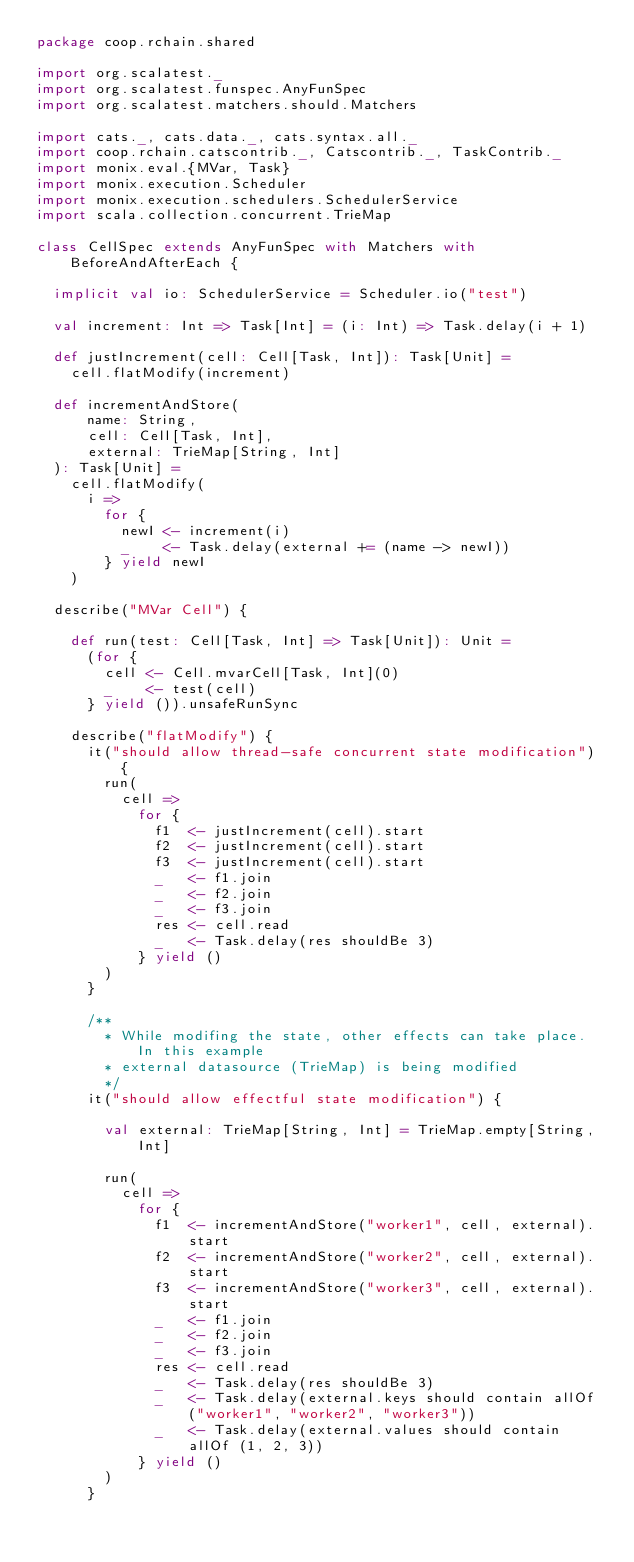Convert code to text. <code><loc_0><loc_0><loc_500><loc_500><_Scala_>package coop.rchain.shared

import org.scalatest._
import org.scalatest.funspec.AnyFunSpec
import org.scalatest.matchers.should.Matchers

import cats._, cats.data._, cats.syntax.all._
import coop.rchain.catscontrib._, Catscontrib._, TaskContrib._
import monix.eval.{MVar, Task}
import monix.execution.Scheduler
import monix.execution.schedulers.SchedulerService
import scala.collection.concurrent.TrieMap

class CellSpec extends AnyFunSpec with Matchers with BeforeAndAfterEach {

  implicit val io: SchedulerService = Scheduler.io("test")

  val increment: Int => Task[Int] = (i: Int) => Task.delay(i + 1)

  def justIncrement(cell: Cell[Task, Int]): Task[Unit] =
    cell.flatModify(increment)

  def incrementAndStore(
      name: String,
      cell: Cell[Task, Int],
      external: TrieMap[String, Int]
  ): Task[Unit] =
    cell.flatModify(
      i =>
        for {
          newI <- increment(i)
          _    <- Task.delay(external += (name -> newI))
        } yield newI
    )

  describe("MVar Cell") {

    def run(test: Cell[Task, Int] => Task[Unit]): Unit =
      (for {
        cell <- Cell.mvarCell[Task, Int](0)
        _    <- test(cell)
      } yield ()).unsafeRunSync

    describe("flatModify") {
      it("should allow thread-safe concurrent state modification") {
        run(
          cell =>
            for {
              f1  <- justIncrement(cell).start
              f2  <- justIncrement(cell).start
              f3  <- justIncrement(cell).start
              _   <- f1.join
              _   <- f2.join
              _   <- f3.join
              res <- cell.read
              _   <- Task.delay(res shouldBe 3)
            } yield ()
        )
      }

      /**
        * While modifing the state, other effects can take place. In this example
        * external datasource (TrieMap) is being modified
        */
      it("should allow effectful state modification") {

        val external: TrieMap[String, Int] = TrieMap.empty[String, Int]

        run(
          cell =>
            for {
              f1  <- incrementAndStore("worker1", cell, external).start
              f2  <- incrementAndStore("worker2", cell, external).start
              f3  <- incrementAndStore("worker3", cell, external).start
              _   <- f1.join
              _   <- f2.join
              _   <- f3.join
              res <- cell.read
              _   <- Task.delay(res shouldBe 3)
              _   <- Task.delay(external.keys should contain allOf ("worker1", "worker2", "worker3"))
              _   <- Task.delay(external.values should contain allOf (1, 2, 3))
            } yield ()
        )
      }
</code> 